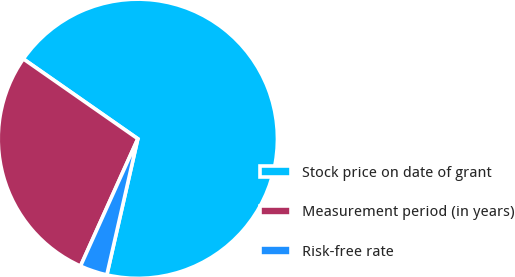Convert chart. <chart><loc_0><loc_0><loc_500><loc_500><pie_chart><fcel>Stock price on date of grant<fcel>Measurement period (in years)<fcel>Risk-free rate<nl><fcel>68.87%<fcel>27.96%<fcel>3.17%<nl></chart> 